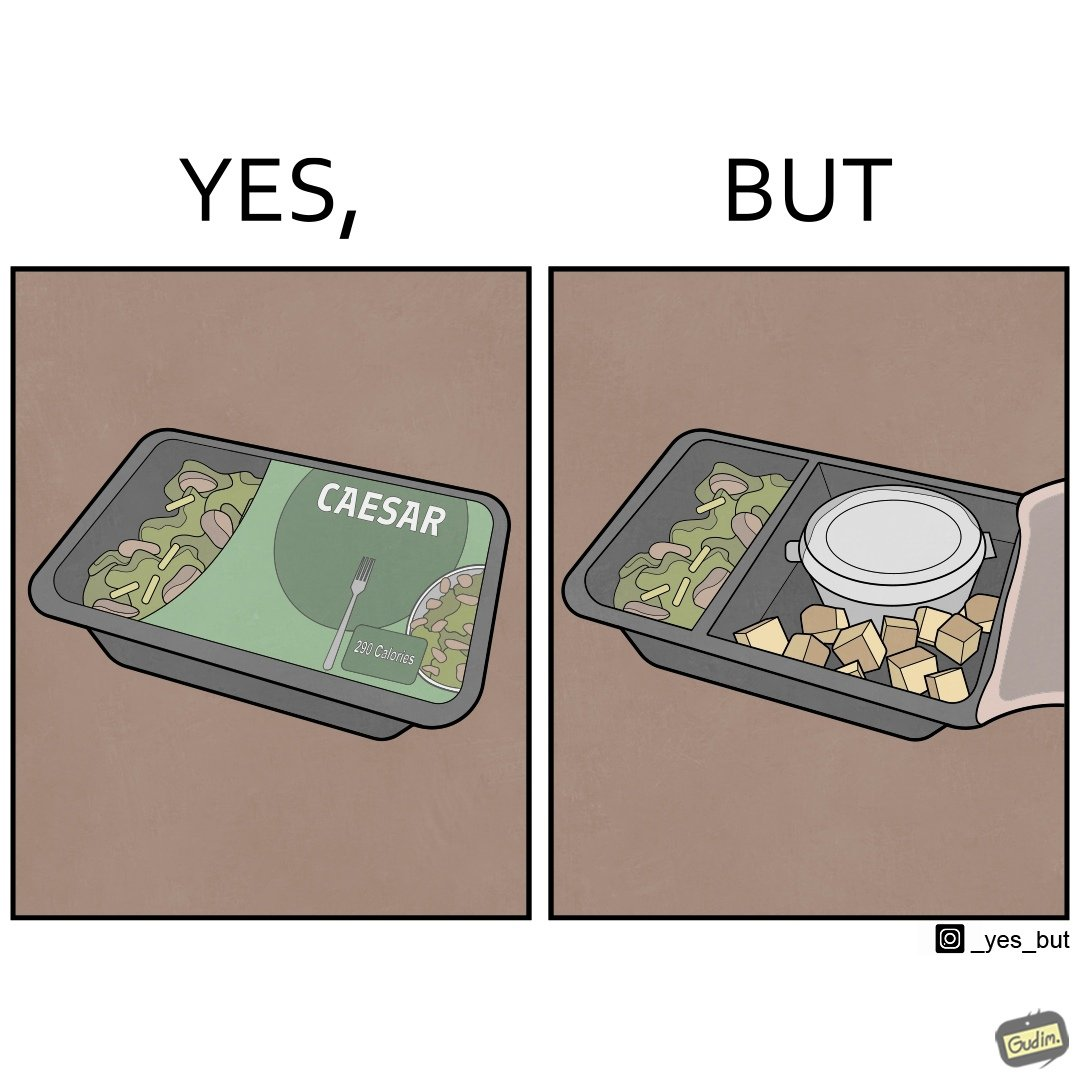Compare the left and right sides of this image. In the left part of the image: A box of healthy salad. The left quarter of its lid is transparent, revealing the greens inside. In the right part of the image: A box of salad that has very little greens. Its left quarter area contains greens, and the other three quarters looks almost empty with only some salad dressing and some  bread crumbs in it. 